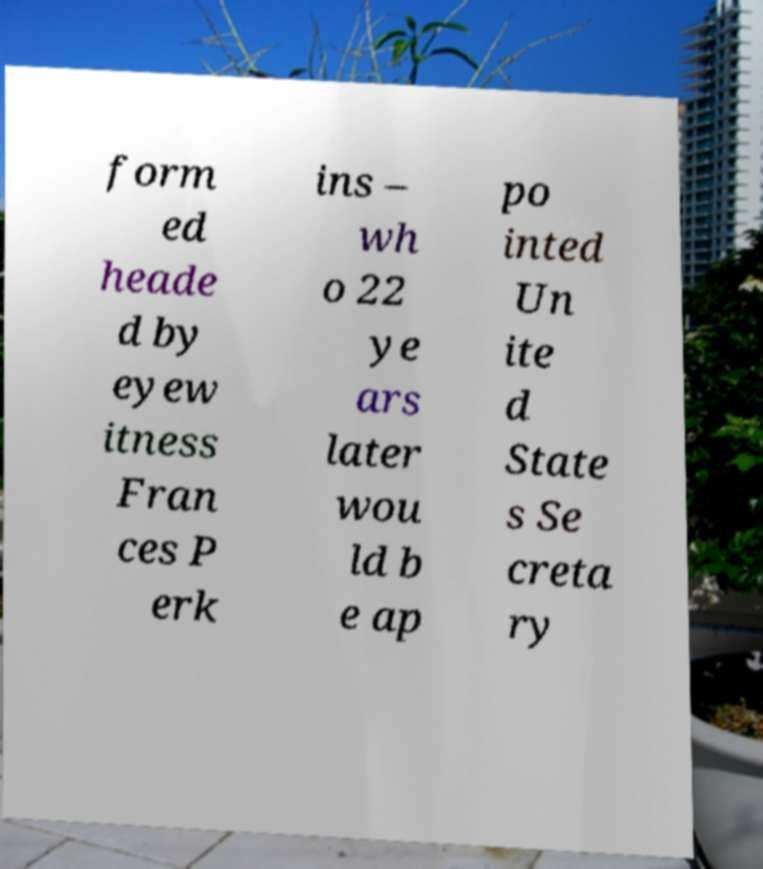For documentation purposes, I need the text within this image transcribed. Could you provide that? form ed heade d by eyew itness Fran ces P erk ins – wh o 22 ye ars later wou ld b e ap po inted Un ite d State s Se creta ry 